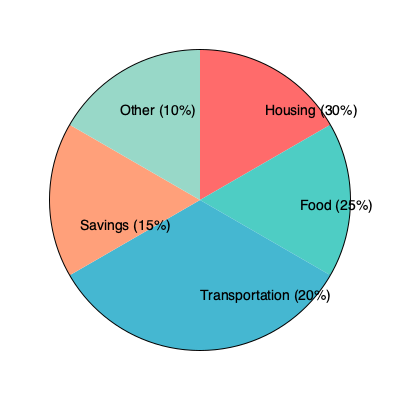As a responsible parent and financial planner, you're analyzing your family's budget allocation. The pie chart shows the breakdown of your monthly expenses. If your total monthly income is $8000, how much are you saving each month, and what percentage of your income goes towards housing and food combined? Let's break this down step-by-step:

1. First, let's identify the relevant percentages from the pie chart:
   - Savings: 15%
   - Housing: 30%
   - Food: 25%

2. To calculate the amount saved each month:
   - Total income: $8000
   - Savings percentage: 15%
   - Savings amount = $8000 * 15% = $8000 * 0.15 = $1200

3. To calculate the percentage of income for housing and food combined:
   - Housing: 30%
   - Food: 25%
   - Combined percentage = 30% + 25% = 55%

Therefore, you're saving $1200 each month, and 55% of your income goes towards housing and food combined.
Answer: $1200 savings; 55% for housing and food 